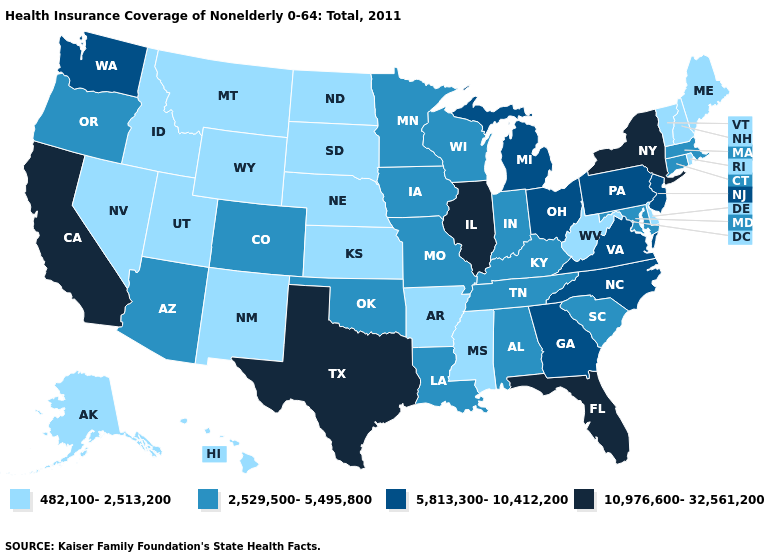Does West Virginia have a lower value than New Mexico?
Short answer required. No. What is the highest value in the South ?
Concise answer only. 10,976,600-32,561,200. Does Wisconsin have a lower value than California?
Give a very brief answer. Yes. Name the states that have a value in the range 5,813,300-10,412,200?
Give a very brief answer. Georgia, Michigan, New Jersey, North Carolina, Ohio, Pennsylvania, Virginia, Washington. What is the value of Pennsylvania?
Quick response, please. 5,813,300-10,412,200. Does California have the highest value in the West?
Short answer required. Yes. Does South Carolina have the highest value in the USA?
Write a very short answer. No. What is the value of Nevada?
Write a very short answer. 482,100-2,513,200. Does Iowa have the lowest value in the USA?
Give a very brief answer. No. What is the highest value in states that border Michigan?
Answer briefly. 5,813,300-10,412,200. Name the states that have a value in the range 10,976,600-32,561,200?
Short answer required. California, Florida, Illinois, New York, Texas. What is the value of New Mexico?
Answer briefly. 482,100-2,513,200. What is the value of Oregon?
Quick response, please. 2,529,500-5,495,800. What is the value of Wyoming?
Write a very short answer. 482,100-2,513,200. What is the value of Tennessee?
Answer briefly. 2,529,500-5,495,800. 